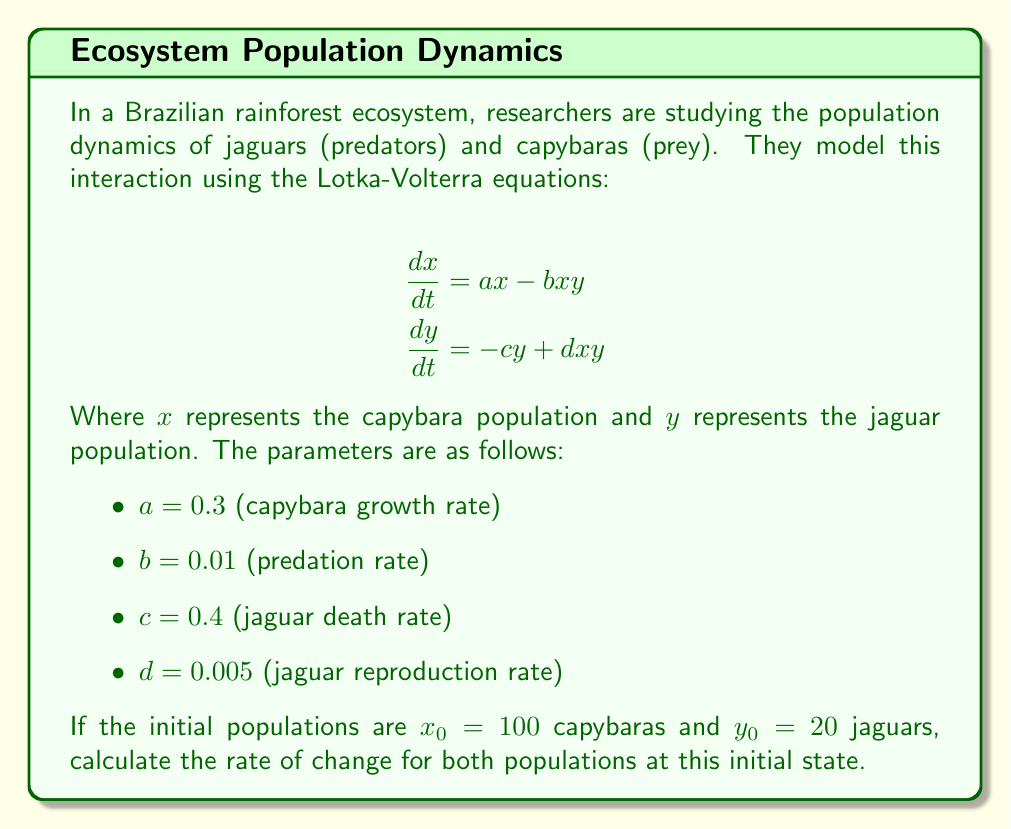What is the answer to this math problem? To solve this problem, we need to use the Lotka-Volterra equations and substitute the given values. Let's approach this step-by-step:

1. For the capybara population (prey):
   $$\frac{dx}{dt} = ax - bxy$$
   
   Substituting the values:
   $$\frac{dx}{dt} = 0.3x - 0.01xy$$
   
   At the initial state:
   $$\frac{dx}{dt} = 0.3(100) - 0.01(100)(20)$$
   $$\frac{dx}{dt} = 30 - 20 = 10$$

2. For the jaguar population (predator):
   $$\frac{dy}{dt} = -cy + dxy$$
   
   Substituting the values:
   $$\frac{dy}{dt} = -0.4y + 0.005xy$$
   
   At the initial state:
   $$\frac{dy}{dt} = -0.4(20) + 0.005(100)(20)$$
   $$\frac{dy}{dt} = -8 + 10 = 2$$

These results show that at the initial state:
- The capybara population is increasing at a rate of 10 individuals per time unit.
- The jaguar population is increasing at a rate of 2 individuals per time unit.

This makes sense ecologically because:
1. The capybara population has a positive growth rate despite predation, indicating that their reproduction rate outpaces the predation rate at this population level.
2. The jaguar population is also growing, albeit more slowly, suggesting that the current prey population is sufficient to support predator growth.
Answer: The rate of change for the capybara population (prey) is $\frac{dx}{dt} = 10$ individuals per time unit, and for the jaguar population (predator) is $\frac{dy}{dt} = 2$ individuals per time unit at the initial state. 